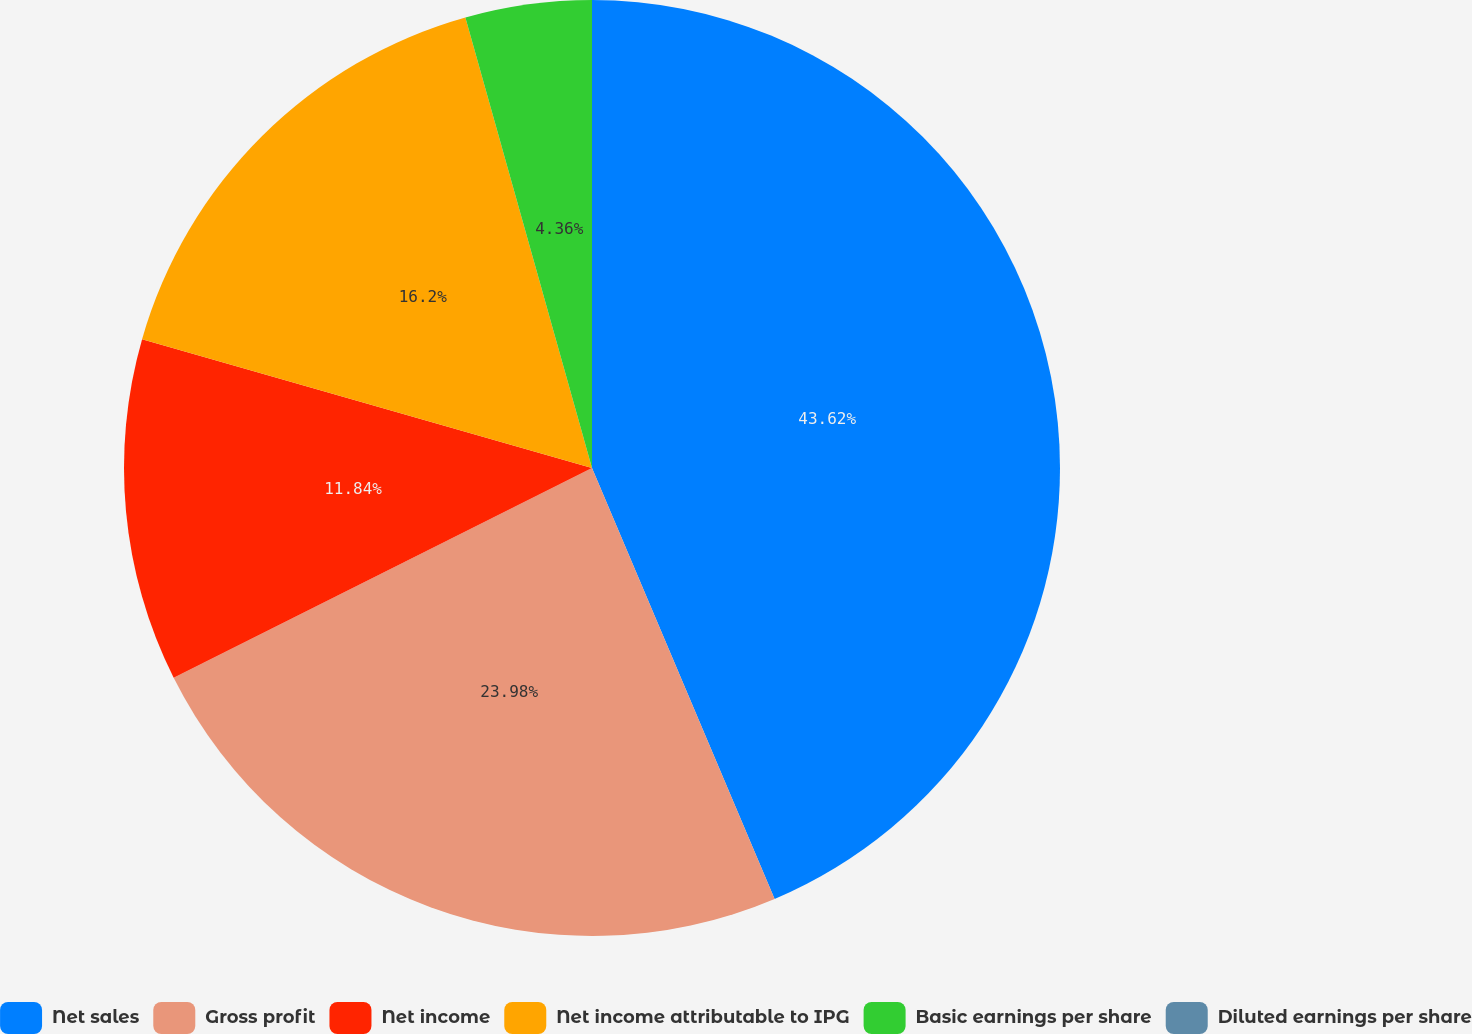Convert chart. <chart><loc_0><loc_0><loc_500><loc_500><pie_chart><fcel>Net sales<fcel>Gross profit<fcel>Net income<fcel>Net income attributable to IPG<fcel>Basic earnings per share<fcel>Diluted earnings per share<nl><fcel>43.62%<fcel>23.98%<fcel>11.84%<fcel>16.2%<fcel>4.36%<fcel>0.0%<nl></chart> 